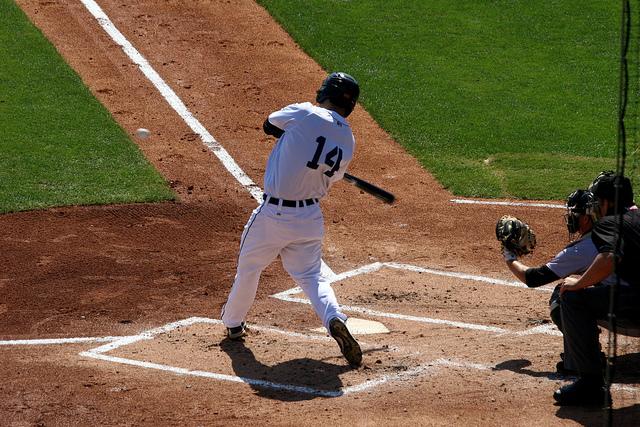What number is on the back of his uniform?
Give a very brief answer. 14. What number is the batter?
Concise answer only. 14. Is this batter swinging at the pitch?
Short answer required. Yes. What inning is this baseball game?
Write a very short answer. 5. What has been used to mark the ground?
Concise answer only. Chalk. What is the batter looking at?
Answer briefly. Ball. 